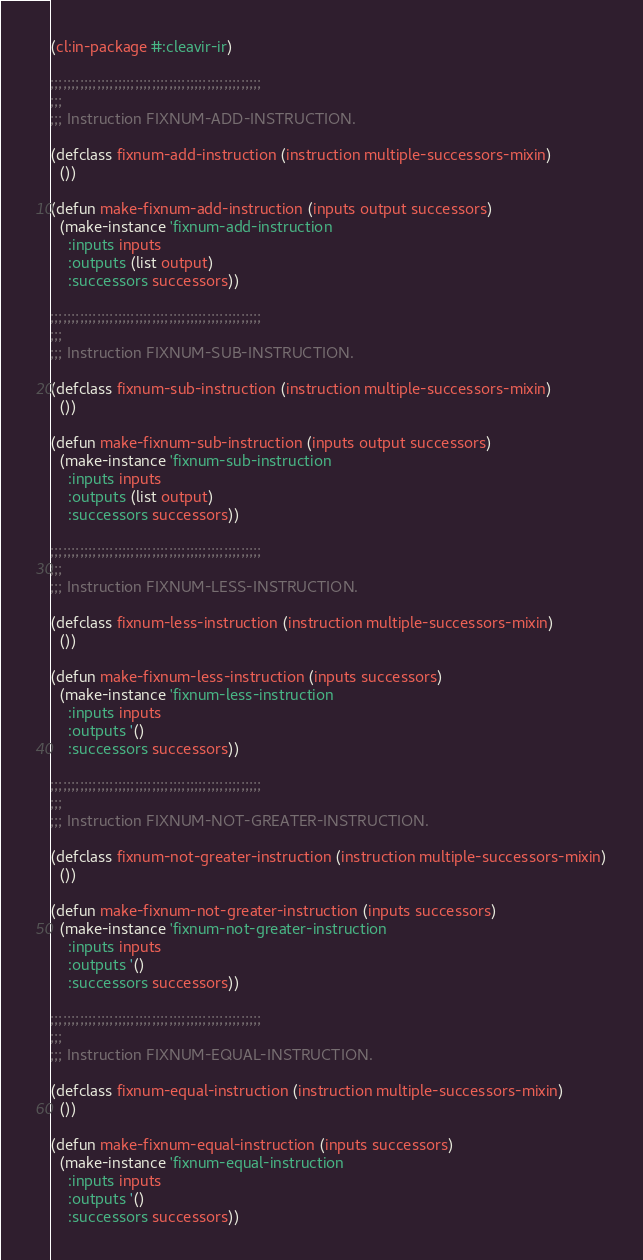<code> <loc_0><loc_0><loc_500><loc_500><_Lisp_>(cl:in-package #:cleavir-ir)

;;;;;;;;;;;;;;;;;;;;;;;;;;;;;;;;;;;;;;;;;;;;;;;;;;
;;;
;;; Instruction FIXNUM-ADD-INSTRUCTION.

(defclass fixnum-add-instruction (instruction multiple-successors-mixin)
  ())

(defun make-fixnum-add-instruction (inputs output successors)
  (make-instance 'fixnum-add-instruction
    :inputs inputs
    :outputs (list output)
    :successors successors))

;;;;;;;;;;;;;;;;;;;;;;;;;;;;;;;;;;;;;;;;;;;;;;;;;;
;;;
;;; Instruction FIXNUM-SUB-INSTRUCTION.

(defclass fixnum-sub-instruction (instruction multiple-successors-mixin)
  ())

(defun make-fixnum-sub-instruction (inputs output successors)
  (make-instance 'fixnum-sub-instruction
    :inputs inputs
    :outputs (list output)
    :successors successors))

;;;;;;;;;;;;;;;;;;;;;;;;;;;;;;;;;;;;;;;;;;;;;;;;;;
;;;
;;; Instruction FIXNUM-LESS-INSTRUCTION.

(defclass fixnum-less-instruction (instruction multiple-successors-mixin)
  ())

(defun make-fixnum-less-instruction (inputs successors)
  (make-instance 'fixnum-less-instruction
    :inputs inputs
    :outputs '()
    :successors successors))

;;;;;;;;;;;;;;;;;;;;;;;;;;;;;;;;;;;;;;;;;;;;;;;;;;
;;;
;;; Instruction FIXNUM-NOT-GREATER-INSTRUCTION.

(defclass fixnum-not-greater-instruction (instruction multiple-successors-mixin)
  ())

(defun make-fixnum-not-greater-instruction (inputs successors)
  (make-instance 'fixnum-not-greater-instruction
    :inputs inputs
    :outputs '()
    :successors successors))

;;;;;;;;;;;;;;;;;;;;;;;;;;;;;;;;;;;;;;;;;;;;;;;;;;
;;;
;;; Instruction FIXNUM-EQUAL-INSTRUCTION.

(defclass fixnum-equal-instruction (instruction multiple-successors-mixin)
  ())

(defun make-fixnum-equal-instruction (inputs successors)
  (make-instance 'fixnum-equal-instruction
    :inputs inputs
    :outputs '()
    :successors successors))
</code> 